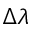<formula> <loc_0><loc_0><loc_500><loc_500>\Delta \lambda</formula> 